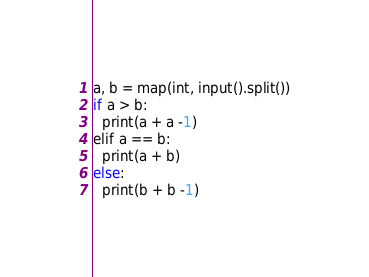Convert code to text. <code><loc_0><loc_0><loc_500><loc_500><_Rust_>a, b = map(int, input().split())
if a > b:
  print(a + a -1)
elif a == b:
  print(a + b)
else:
  print(b + b -1)
</code> 